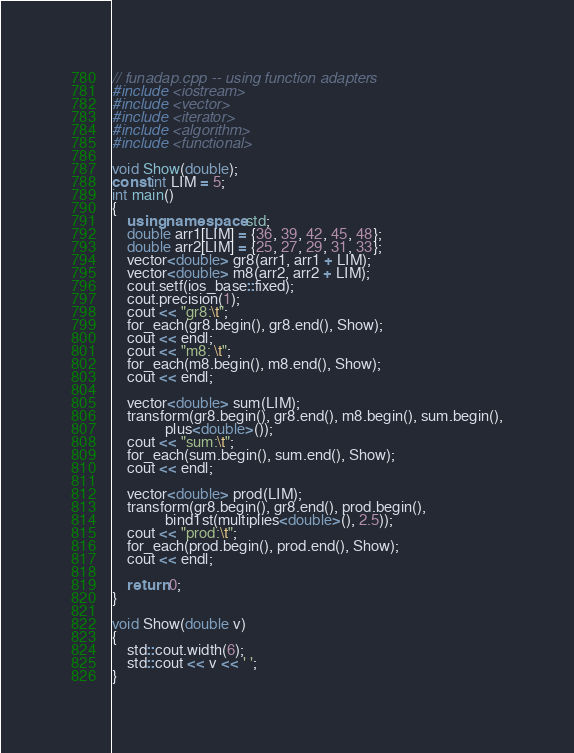Convert code to text. <code><loc_0><loc_0><loc_500><loc_500><_C++_>// funadap.cpp -- using function adapters
#include <iostream>
#include <vector>
#include <iterator>
#include <algorithm>
#include <functional>

void Show(double);
const int LIM = 5;
int main()
{
    using namespace std;
    double arr1[LIM] = {36, 39, 42, 45, 48};
    double arr2[LIM] = {25, 27, 29, 31, 33};
    vector<double> gr8(arr1, arr1 + LIM);
    vector<double> m8(arr2, arr2 + LIM);
    cout.setf(ios_base::fixed);
    cout.precision(1);
    cout << "gr8:\t";
    for_each(gr8.begin(), gr8.end(), Show);
    cout << endl;
    cout << "m8: \t";
    for_each(m8.begin(), m8.end(), Show);
    cout << endl;

    vector<double> sum(LIM);
    transform(gr8.begin(), gr8.end(), m8.begin(), sum.begin(),
              plus<double>());
    cout << "sum:\t";
    for_each(sum.begin(), sum.end(), Show);
    cout << endl;

    vector<double> prod(LIM);
    transform(gr8.begin(), gr8.end(), prod.begin(),
              bind1st(multiplies<double>(), 2.5));
    cout << "prod:\t";
    for_each(prod.begin(), prod.end(), Show);
    cout << endl;

    return 0; 
}

void Show(double v)
{
    std::cout.width(6);
    std::cout << v << ' '; 
}
</code> 